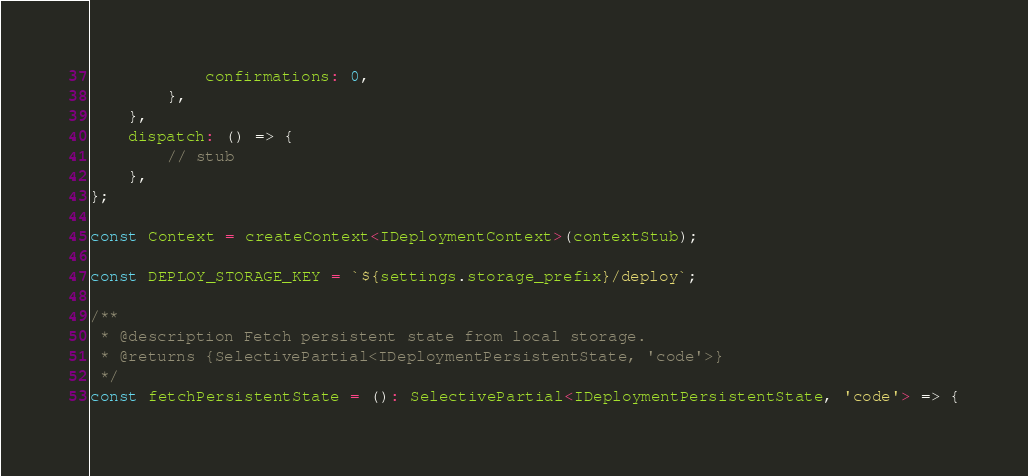<code> <loc_0><loc_0><loc_500><loc_500><_TypeScript_>            confirmations: 0,
        },
    },
    dispatch: () => {
        // stub
    },
};

const Context = createContext<IDeploymentContext>(contextStub);

const DEPLOY_STORAGE_KEY = `${settings.storage_prefix}/deploy`;

/**
 * @description Fetch persistent state from local storage.
 * @returns {SelectivePartial<IDeploymentPersistentState, 'code'>}
 */
const fetchPersistentState = (): SelectivePartial<IDeploymentPersistentState, 'code'> => {</code> 